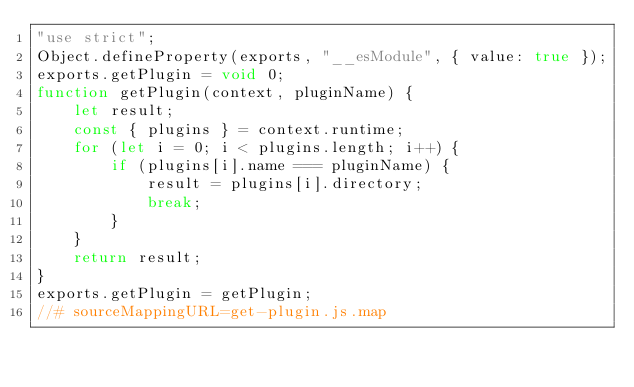<code> <loc_0><loc_0><loc_500><loc_500><_JavaScript_>"use strict";
Object.defineProperty(exports, "__esModule", { value: true });
exports.getPlugin = void 0;
function getPlugin(context, pluginName) {
    let result;
    const { plugins } = context.runtime;
    for (let i = 0; i < plugins.length; i++) {
        if (plugins[i].name === pluginName) {
            result = plugins[i].directory;
            break;
        }
    }
    return result;
}
exports.getPlugin = getPlugin;
//# sourceMappingURL=get-plugin.js.map</code> 